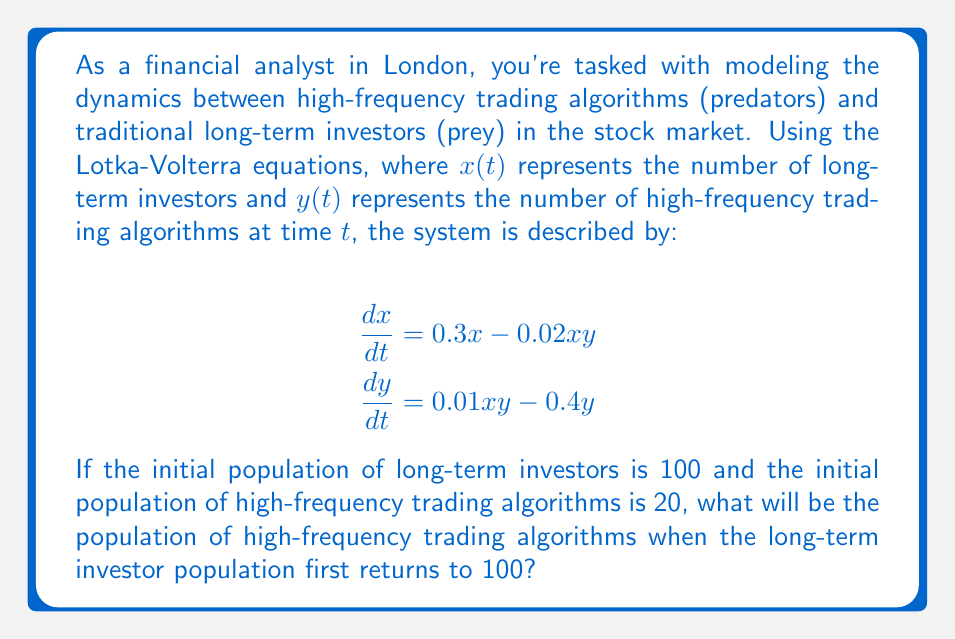Show me your answer to this math problem. To solve this problem, we'll use the concept of conservation of energy in the Lotka-Volterra system. The system has a first integral, which represents the energy of the system and remains constant over time. This integral is given by:

$$E = 0.4 \ln(x) + 0.3 \ln(y) - 0.01x - 0.02y$$

1) First, calculate the initial energy of the system:
   $E_0 = 0.4 \ln(100) + 0.3 \ln(20) - 0.01(100) - 0.02(20)$
   $E_0 = 0.4(4.6052) + 0.3(2.9957) - 1 - 0.4$
   $E_0 = 1.8421 + 0.8987 - 1.4 = 1.3408$

2) When the long-term investor population returns to 100, we know that $x = 100$ again. Let's call the unknown population of high-frequency trading algorithms at this point $y_1$. We can set up an equation using the conservation of energy:

   $1.3408 = 0.4 \ln(100) + 0.3 \ln(y_1) - 0.01(100) - 0.02y_1$

3) Simplify:
   $1.3408 = 1.8421 + 0.3 \ln(y_1) - 1 - 0.02y_1$
   $0.4987 = 0.3 \ln(y_1) - 0.02y_1$

4) This equation can't be solved algebraically, so we need to use numerical methods. Using a graphing calculator or computer software, we can find that the solution is approximately:

   $y_1 \approx 14.7385$

Therefore, when the long-term investor population first returns to 100, the population of high-frequency trading algorithms will be approximately 14.7385.
Answer: Approximately 14.74 high-frequency trading algorithms 